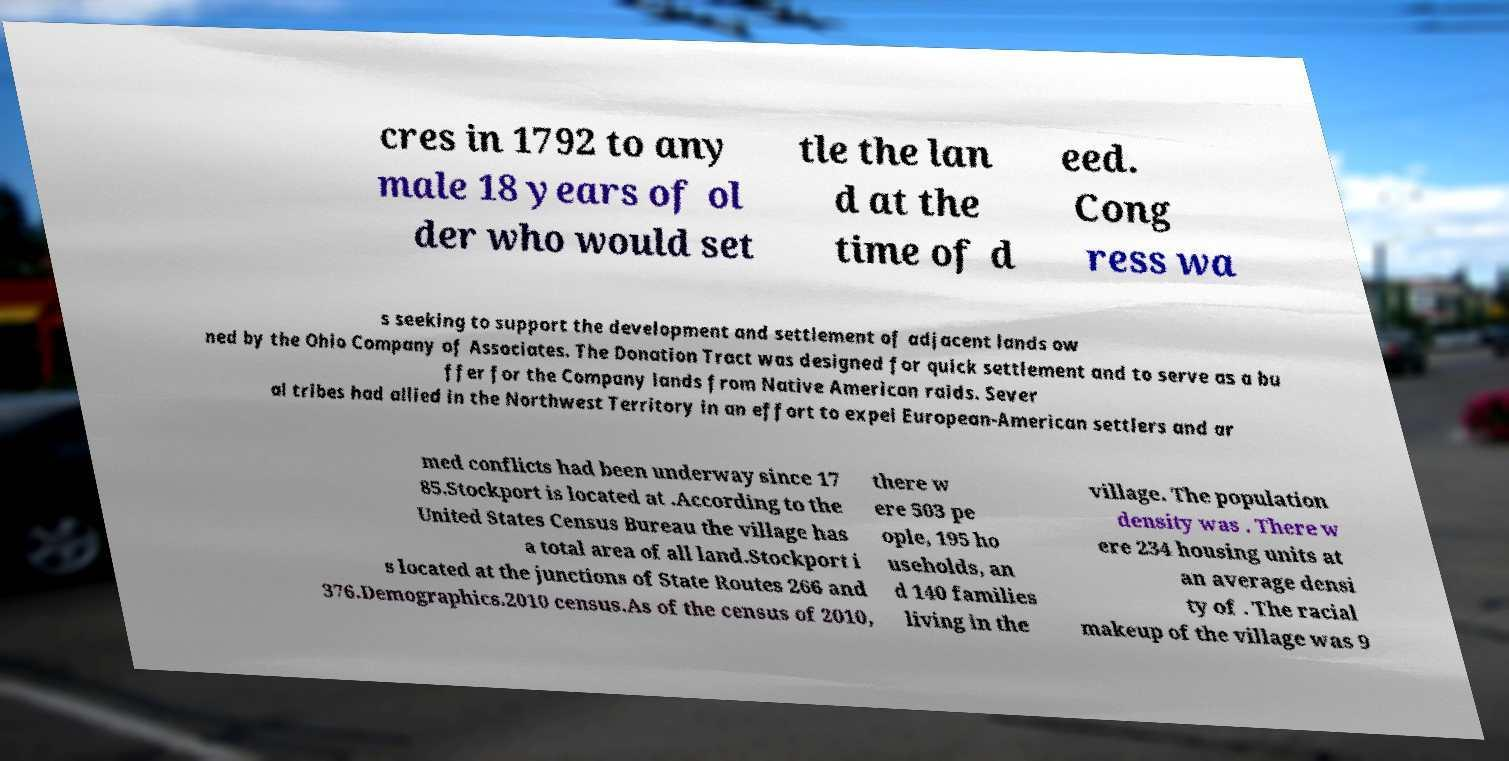Can you accurately transcribe the text from the provided image for me? cres in 1792 to any male 18 years of ol der who would set tle the lan d at the time of d eed. Cong ress wa s seeking to support the development and settlement of adjacent lands ow ned by the Ohio Company of Associates. The Donation Tract was designed for quick settlement and to serve as a bu ffer for the Company lands from Native American raids. Sever al tribes had allied in the Northwest Territory in an effort to expel European-American settlers and ar med conflicts had been underway since 17 85.Stockport is located at .According to the United States Census Bureau the village has a total area of all land.Stockport i s located at the junctions of State Routes 266 and 376.Demographics.2010 census.As of the census of 2010, there w ere 503 pe ople, 195 ho useholds, an d 140 families living in the village. The population density was . There w ere 234 housing units at an average densi ty of . The racial makeup of the village was 9 